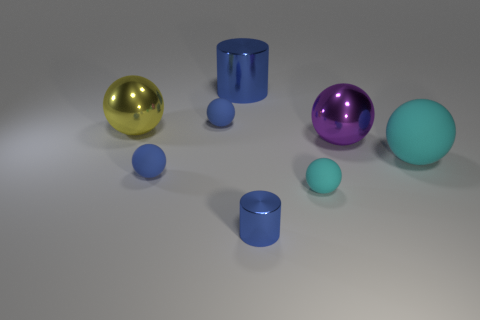There is a tiny cyan thing that is the same shape as the large yellow metallic thing; what is its material?
Give a very brief answer. Rubber. There is a large rubber object that is right of the small ball on the right side of the small shiny object; are there any cylinders in front of it?
Your answer should be compact. Yes. Is the shape of the tiny metal thing the same as the small rubber object to the right of the big blue shiny thing?
Your answer should be very brief. No. Is there anything else that is the same color as the small metal object?
Offer a very short reply. Yes. There is a small ball behind the yellow metal object; is its color the same as the cylinder that is behind the purple thing?
Your response must be concise. Yes. Is there a big blue metal cylinder?
Offer a very short reply. Yes. Is there a tiny blue sphere made of the same material as the large purple thing?
Offer a very short reply. No. Is there any other thing that is the same material as the big cylinder?
Your response must be concise. Yes. What is the color of the large metallic cylinder?
Ensure brevity in your answer.  Blue. There is another object that is the same color as the large matte thing; what is its shape?
Provide a succinct answer. Sphere. 